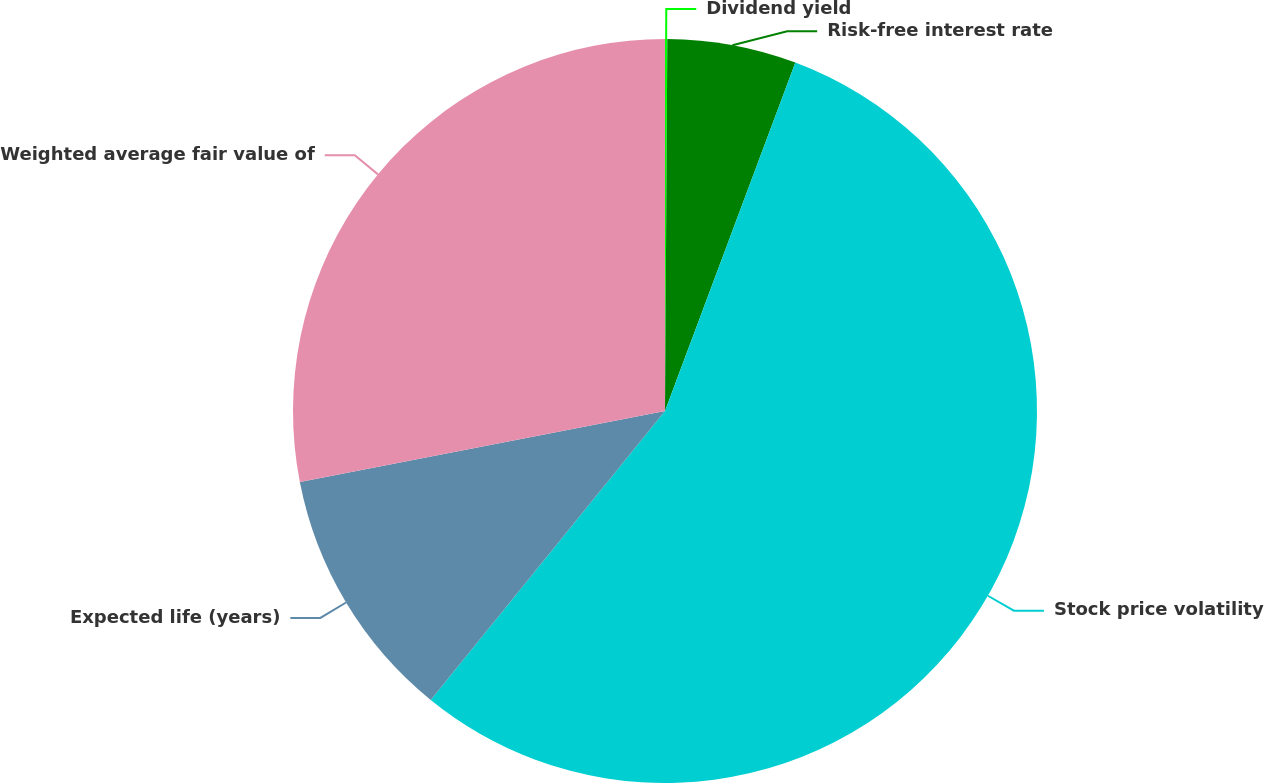<chart> <loc_0><loc_0><loc_500><loc_500><pie_chart><fcel>Dividend yield<fcel>Risk-free interest rate<fcel>Stock price volatility<fcel>Expected life (years)<fcel>Weighted average fair value of<nl><fcel>0.1%<fcel>5.6%<fcel>55.15%<fcel>11.1%<fcel>28.06%<nl></chart> 